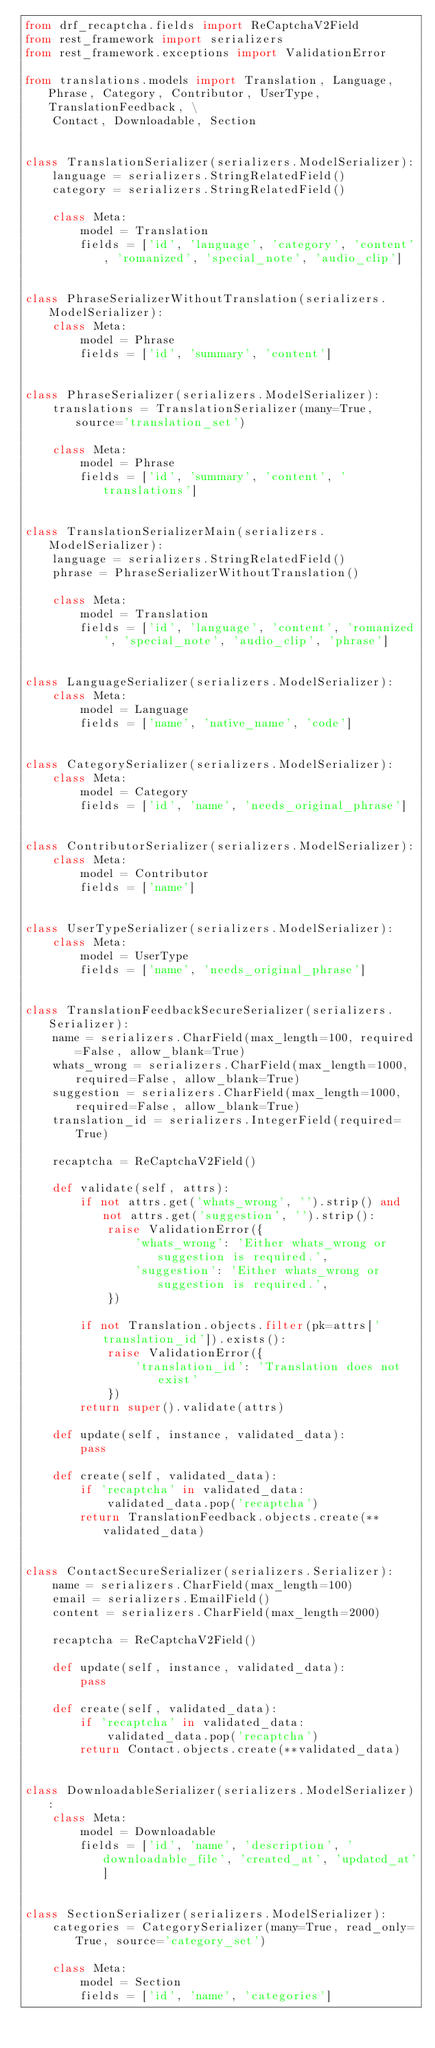<code> <loc_0><loc_0><loc_500><loc_500><_Python_>from drf_recaptcha.fields import ReCaptchaV2Field
from rest_framework import serializers
from rest_framework.exceptions import ValidationError

from translations.models import Translation, Language, Phrase, Category, Contributor, UserType, TranslationFeedback, \
    Contact, Downloadable, Section


class TranslationSerializer(serializers.ModelSerializer):
    language = serializers.StringRelatedField()
    category = serializers.StringRelatedField()

    class Meta:
        model = Translation
        fields = ['id', 'language', 'category', 'content', 'romanized', 'special_note', 'audio_clip']


class PhraseSerializerWithoutTranslation(serializers.ModelSerializer):
    class Meta:
        model = Phrase
        fields = ['id', 'summary', 'content']


class PhraseSerializer(serializers.ModelSerializer):
    translations = TranslationSerializer(many=True, source='translation_set')

    class Meta:
        model = Phrase
        fields = ['id', 'summary', 'content', 'translations']


class TranslationSerializerMain(serializers.ModelSerializer):
    language = serializers.StringRelatedField()
    phrase = PhraseSerializerWithoutTranslation()

    class Meta:
        model = Translation
        fields = ['id', 'language', 'content', 'romanized', 'special_note', 'audio_clip', 'phrase']


class LanguageSerializer(serializers.ModelSerializer):
    class Meta:
        model = Language
        fields = ['name', 'native_name', 'code']


class CategorySerializer(serializers.ModelSerializer):
    class Meta:
        model = Category
        fields = ['id', 'name', 'needs_original_phrase']


class ContributorSerializer(serializers.ModelSerializer):
    class Meta:
        model = Contributor
        fields = ['name']


class UserTypeSerializer(serializers.ModelSerializer):
    class Meta:
        model = UserType
        fields = ['name', 'needs_original_phrase']


class TranslationFeedbackSecureSerializer(serializers.Serializer):
    name = serializers.CharField(max_length=100, required=False, allow_blank=True)
    whats_wrong = serializers.CharField(max_length=1000, required=False, allow_blank=True)
    suggestion = serializers.CharField(max_length=1000, required=False, allow_blank=True)
    translation_id = serializers.IntegerField(required=True)

    recaptcha = ReCaptchaV2Field()

    def validate(self, attrs):
        if not attrs.get('whats_wrong', '').strip() and not attrs.get('suggestion', '').strip():
            raise ValidationError({
                'whats_wrong': 'Either whats_wrong or suggestion is required.',
                'suggestion': 'Either whats_wrong or suggestion is required.',
            })

        if not Translation.objects.filter(pk=attrs['translation_id']).exists():
            raise ValidationError({
                'translation_id': 'Translation does not exist'
            })
        return super().validate(attrs)

    def update(self, instance, validated_data):
        pass

    def create(self, validated_data):
        if 'recaptcha' in validated_data:
            validated_data.pop('recaptcha')
        return TranslationFeedback.objects.create(**validated_data)


class ContactSecureSerializer(serializers.Serializer):
    name = serializers.CharField(max_length=100)
    email = serializers.EmailField()
    content = serializers.CharField(max_length=2000)

    recaptcha = ReCaptchaV2Field()

    def update(self, instance, validated_data):
        pass

    def create(self, validated_data):
        if 'recaptcha' in validated_data:
            validated_data.pop('recaptcha')
        return Contact.objects.create(**validated_data)


class DownloadableSerializer(serializers.ModelSerializer):
    class Meta:
        model = Downloadable
        fields = ['id', 'name', 'description', 'downloadable_file', 'created_at', 'updated_at']


class SectionSerializer(serializers.ModelSerializer):
    categories = CategorySerializer(many=True, read_only=True, source='category_set')

    class Meta:
        model = Section
        fields = ['id', 'name', 'categories']
</code> 